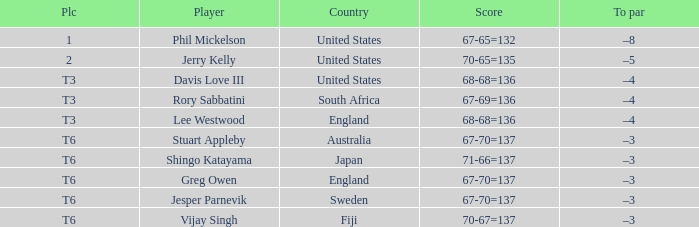Name the score for vijay singh 70-67=137. 